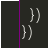<code> <loc_0><loc_0><loc_500><loc_500><_JavaScript_>  })
})
</code> 